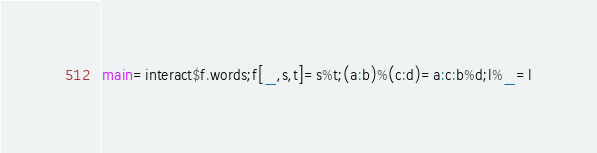<code> <loc_0><loc_0><loc_500><loc_500><_Haskell_>main=interact$f.words;f[_,s,t]=s%t;(a:b)%(c:d)=a:c:b%d;l%_=l</code> 